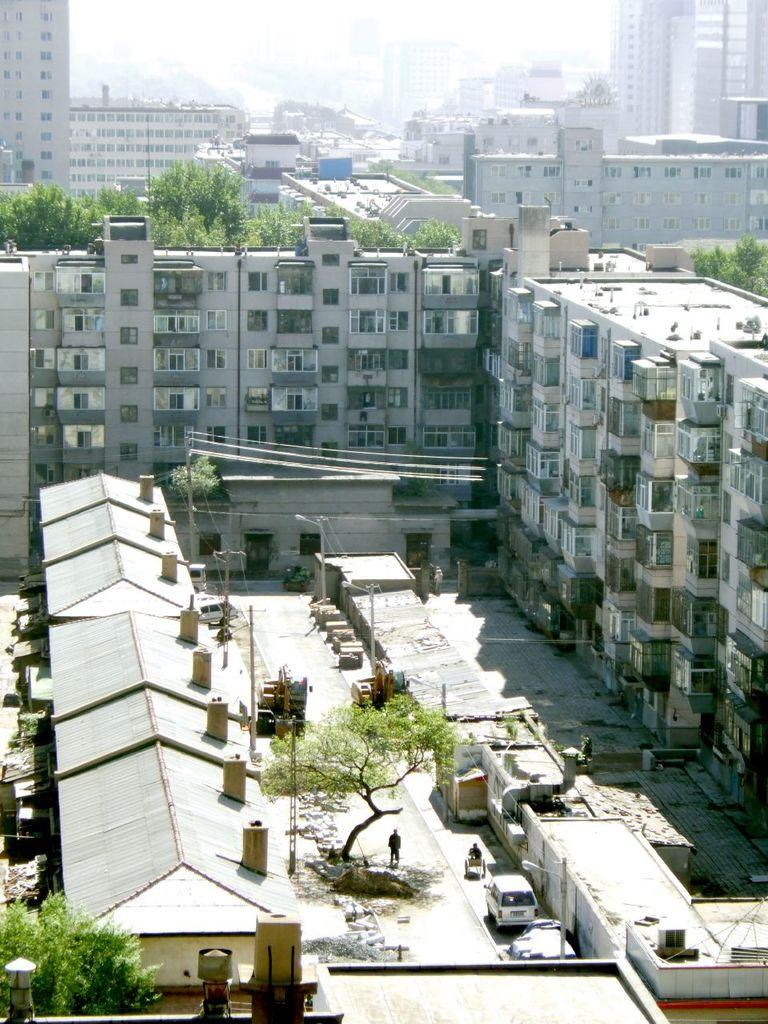What type of structures can be seen in the image? There are buildings and houses in the image. What else can be seen in the image besides structures? There are trees, a car, and people in the image. Can you describe the weather condition in the image? The sky is cloudy in the image. What grade is the tree in the image? There is no tree mentioned in the image, so it is not possible to determine its grade. 